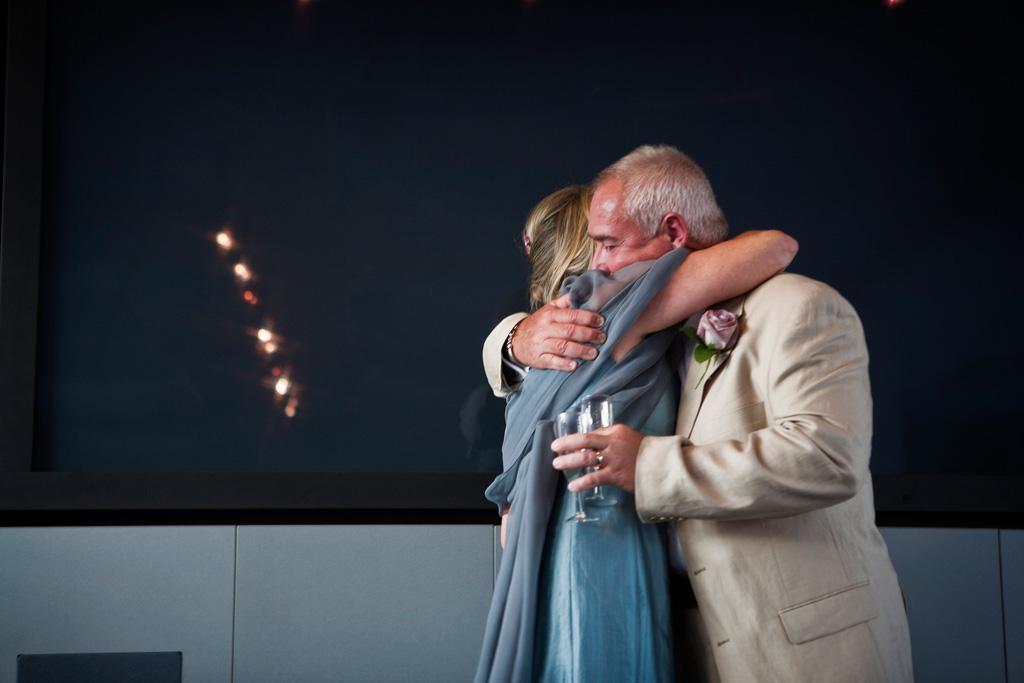Can you describe this image briefly? In this picture we can see a flower, two people and a man holding glasses with his hands and in the background we can see the lights, wall and some objects. 